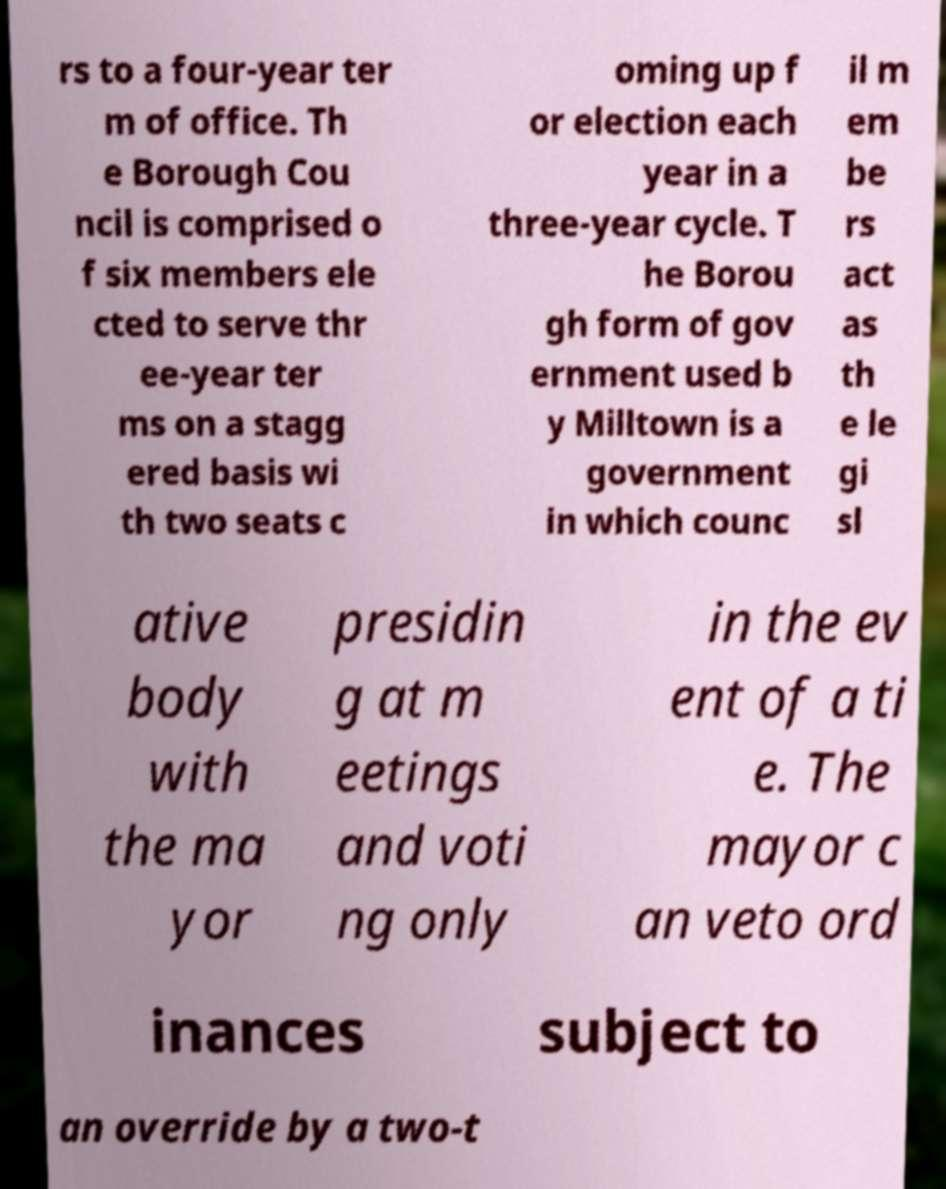What messages or text are displayed in this image? I need them in a readable, typed format. rs to a four-year ter m of office. Th e Borough Cou ncil is comprised o f six members ele cted to serve thr ee-year ter ms on a stagg ered basis wi th two seats c oming up f or election each year in a three-year cycle. T he Borou gh form of gov ernment used b y Milltown is a government in which counc il m em be rs act as th e le gi sl ative body with the ma yor presidin g at m eetings and voti ng only in the ev ent of a ti e. The mayor c an veto ord inances subject to an override by a two-t 